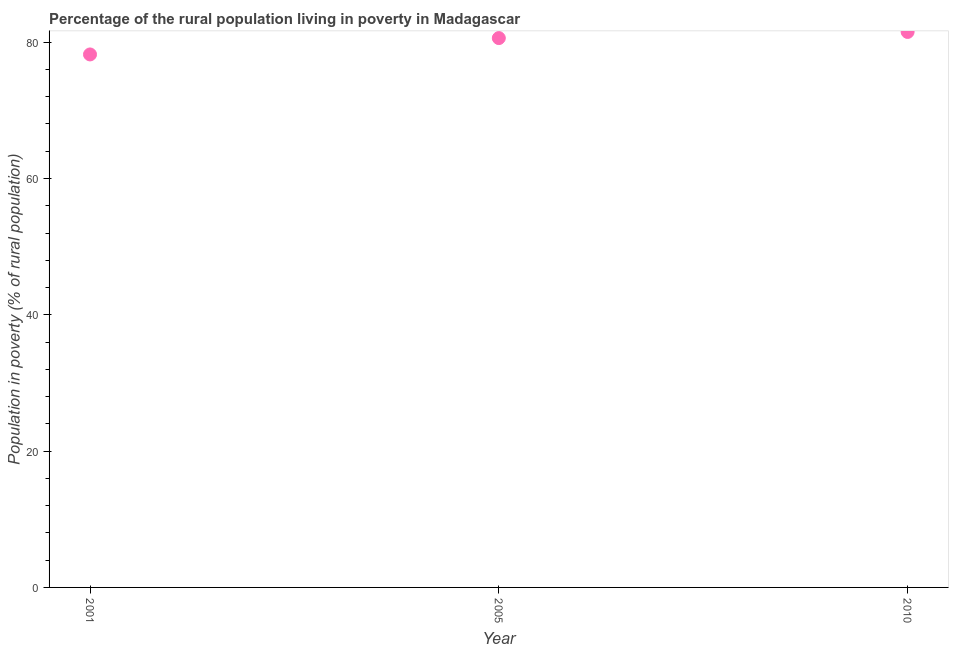What is the percentage of rural population living below poverty line in 2005?
Give a very brief answer. 80.6. Across all years, what is the maximum percentage of rural population living below poverty line?
Provide a short and direct response. 81.5. Across all years, what is the minimum percentage of rural population living below poverty line?
Your response must be concise. 78.2. What is the sum of the percentage of rural population living below poverty line?
Keep it short and to the point. 240.3. What is the difference between the percentage of rural population living below poverty line in 2005 and 2010?
Make the answer very short. -0.9. What is the average percentage of rural population living below poverty line per year?
Give a very brief answer. 80.1. What is the median percentage of rural population living below poverty line?
Your response must be concise. 80.6. In how many years, is the percentage of rural population living below poverty line greater than 8 %?
Your answer should be very brief. 3. Do a majority of the years between 2001 and 2005 (inclusive) have percentage of rural population living below poverty line greater than 68 %?
Give a very brief answer. Yes. What is the ratio of the percentage of rural population living below poverty line in 2005 to that in 2010?
Keep it short and to the point. 0.99. Is the percentage of rural population living below poverty line in 2001 less than that in 2010?
Your answer should be compact. Yes. Is the difference between the percentage of rural population living below poverty line in 2001 and 2010 greater than the difference between any two years?
Ensure brevity in your answer.  Yes. What is the difference between the highest and the second highest percentage of rural population living below poverty line?
Offer a very short reply. 0.9. What is the difference between the highest and the lowest percentage of rural population living below poverty line?
Your answer should be very brief. 3.3. Does the percentage of rural population living below poverty line monotonically increase over the years?
Your response must be concise. Yes. How many dotlines are there?
Your response must be concise. 1. How many years are there in the graph?
Ensure brevity in your answer.  3. Does the graph contain any zero values?
Your answer should be compact. No. Does the graph contain grids?
Your answer should be compact. No. What is the title of the graph?
Offer a terse response. Percentage of the rural population living in poverty in Madagascar. What is the label or title of the Y-axis?
Give a very brief answer. Population in poverty (% of rural population). What is the Population in poverty (% of rural population) in 2001?
Your answer should be very brief. 78.2. What is the Population in poverty (% of rural population) in 2005?
Make the answer very short. 80.6. What is the Population in poverty (% of rural population) in 2010?
Offer a terse response. 81.5. What is the difference between the Population in poverty (% of rural population) in 2001 and 2010?
Provide a short and direct response. -3.3. What is the difference between the Population in poverty (% of rural population) in 2005 and 2010?
Offer a very short reply. -0.9. What is the ratio of the Population in poverty (% of rural population) in 2005 to that in 2010?
Keep it short and to the point. 0.99. 